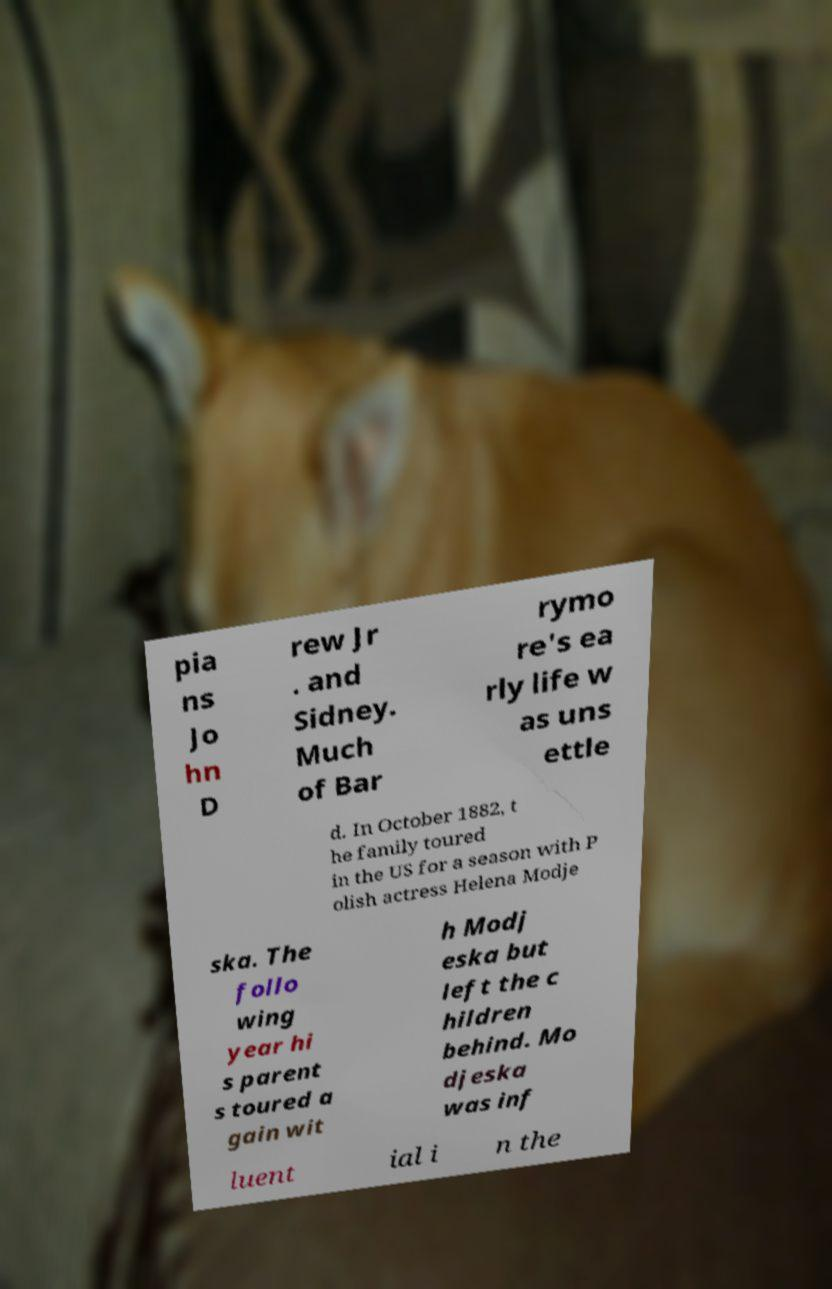Can you read and provide the text displayed in the image?This photo seems to have some interesting text. Can you extract and type it out for me? pia ns Jo hn D rew Jr . and Sidney. Much of Bar rymo re's ea rly life w as uns ettle d. In October 1882, t he family toured in the US for a season with P olish actress Helena Modje ska. The follo wing year hi s parent s toured a gain wit h Modj eska but left the c hildren behind. Mo djeska was inf luent ial i n the 